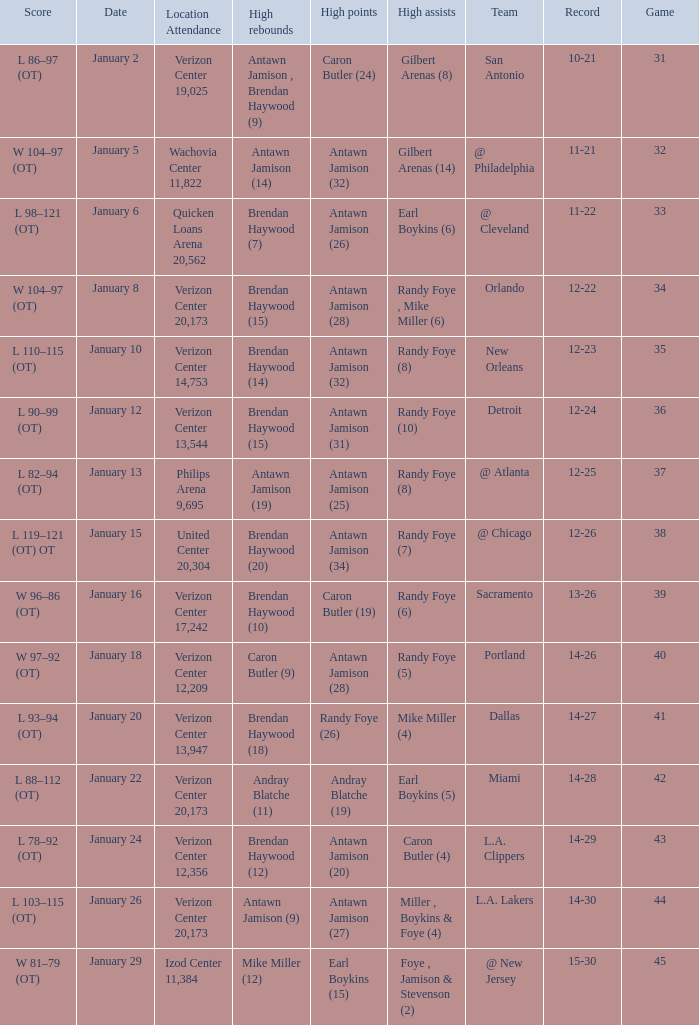Who had the highest points on January 2? Caron Butler (24). 